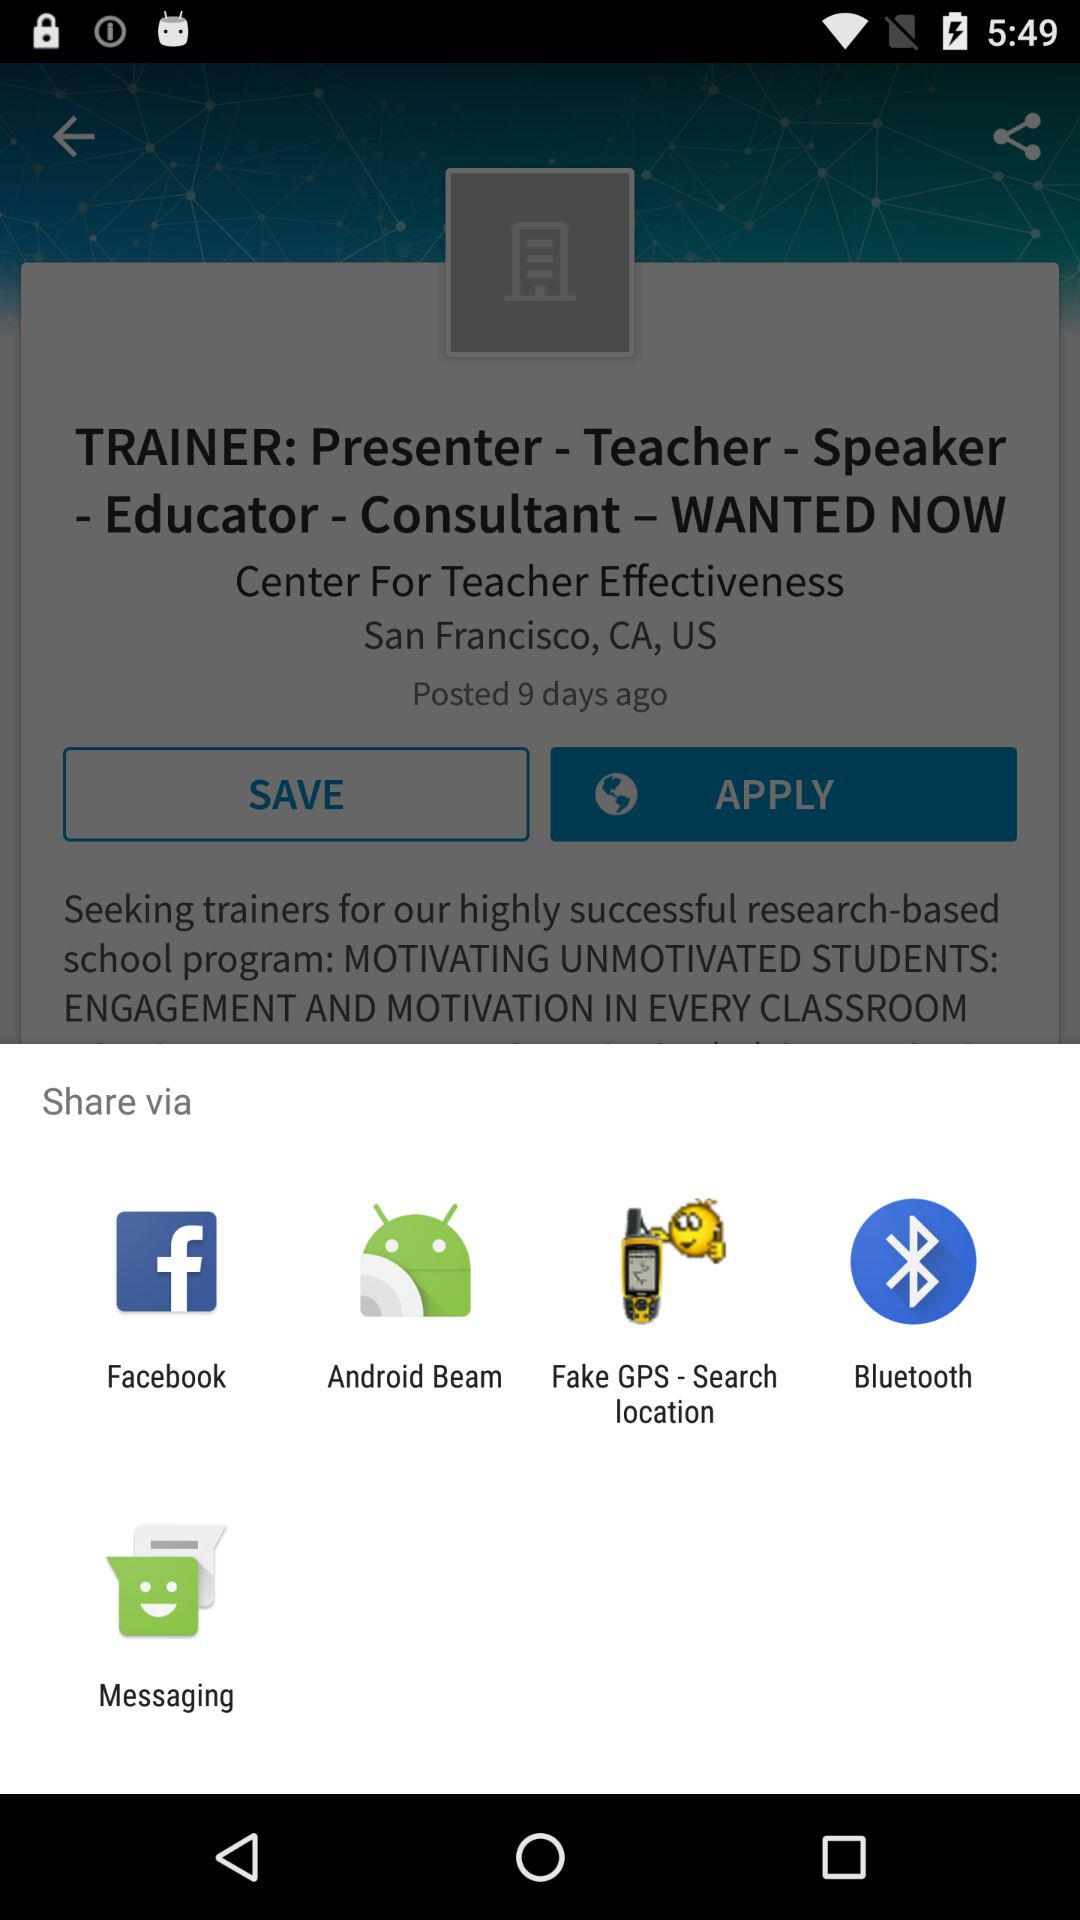What are the options available for sharing? The available options are "Facebook", "Android Beam", "Fake GPS - Search location", "Bluetooth", and "Messaging". 